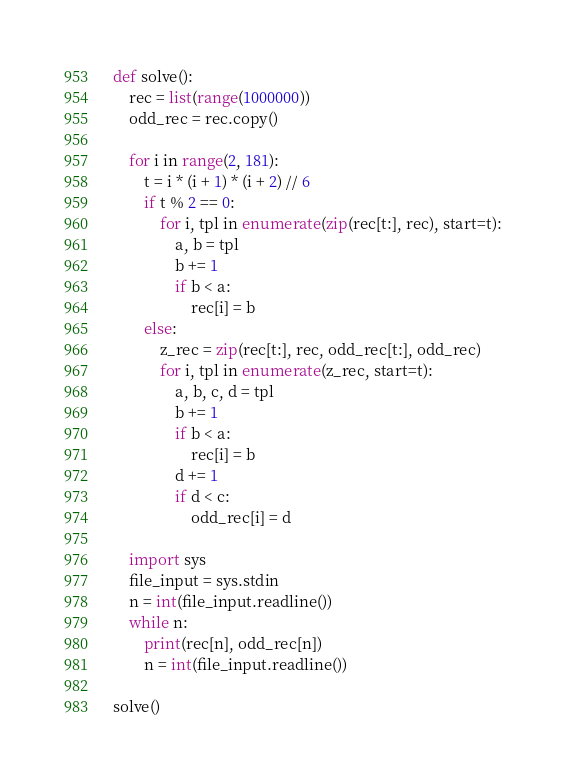Convert code to text. <code><loc_0><loc_0><loc_500><loc_500><_Python_>def solve():
    rec = list(range(1000000))
    odd_rec = rec.copy()
    
    for i in range(2, 181):
        t = i * (i + 1) * (i + 2) // 6
        if t % 2 == 0:
            for i, tpl in enumerate(zip(rec[t:], rec), start=t):
                a, b = tpl
                b += 1
                if b < a:
                    rec[i] = b
        else:
            z_rec = zip(rec[t:], rec, odd_rec[t:], odd_rec)
            for i, tpl in enumerate(z_rec, start=t):
                a, b, c, d = tpl
                b += 1
                if b < a:
                    rec[i] = b
                d += 1
                if d < c:
                    odd_rec[i] = d
    
    import sys
    file_input = sys.stdin
    n = int(file_input.readline())
    while n:
        print(rec[n], odd_rec[n])
        n = int(file_input.readline())

solve()
</code> 